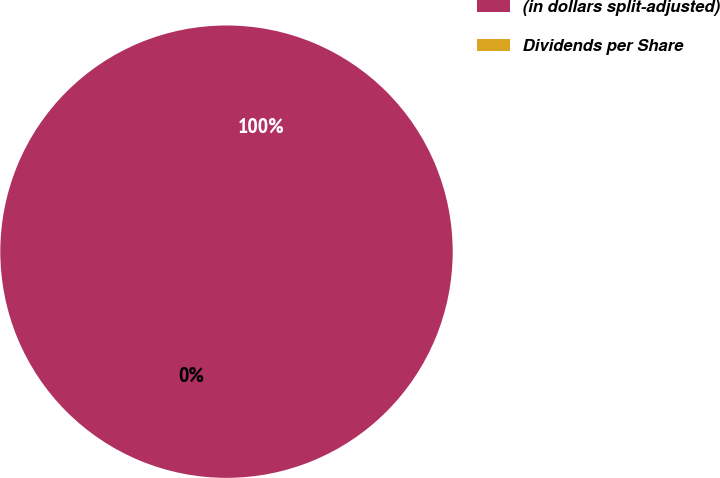Convert chart to OTSL. <chart><loc_0><loc_0><loc_500><loc_500><pie_chart><fcel>(in dollars split-adjusted)<fcel>Dividends per Share<nl><fcel>100.0%<fcel>0.0%<nl></chart> 